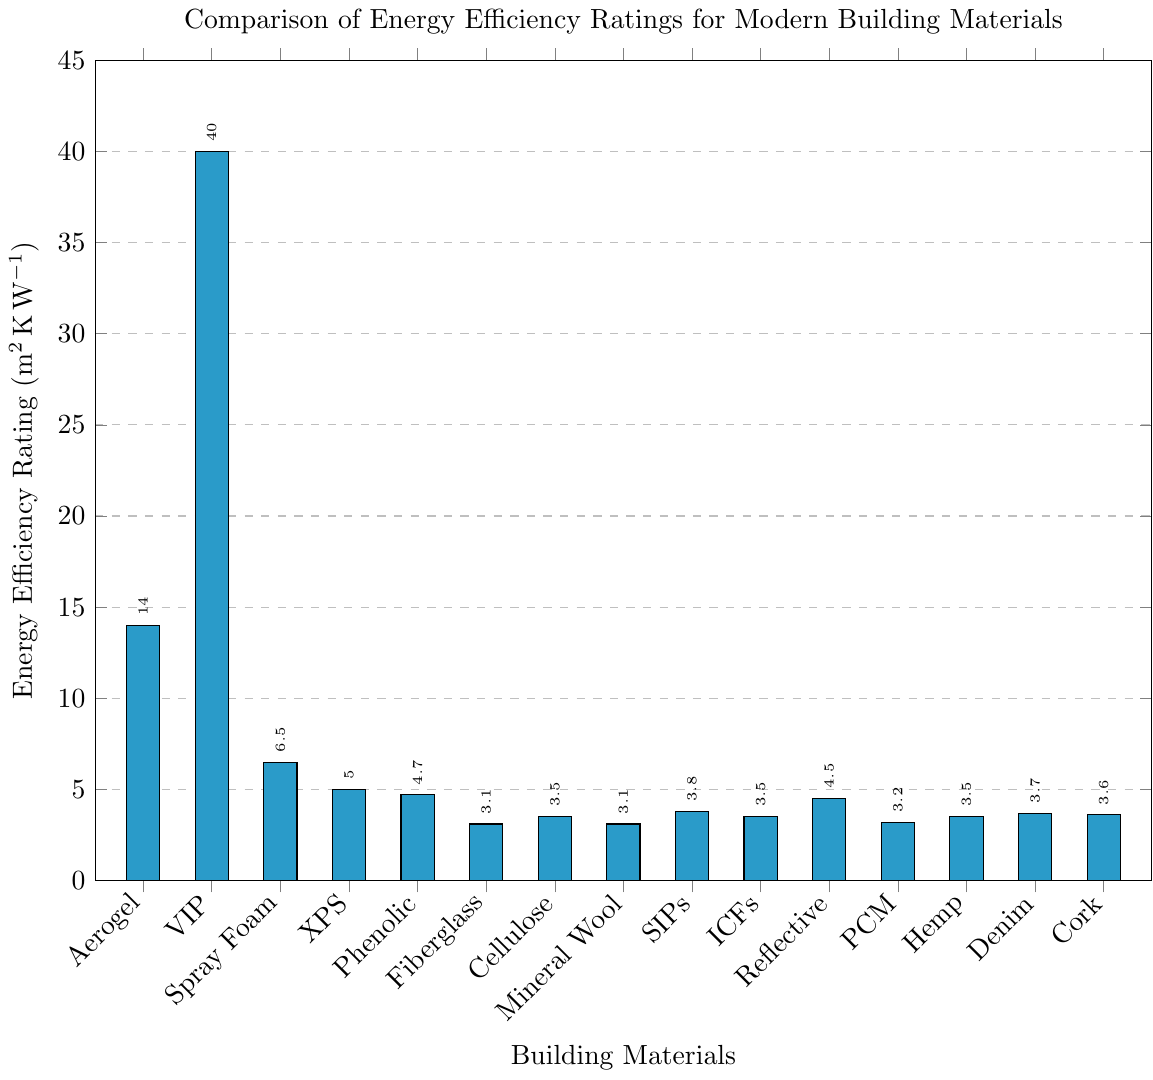Which building material has the highest energy efficiency rating? The figure shows the energy efficiency ratings for various building materials. The tallest bar represents the material with the highest rating.
Answer: Vacuum Insulated Panels What is the difference in energy efficiency rating between Aerogel Insulation and Polyurethane Spray Foam? Locate the bars for Aerogel Insulation and Polyurethane Spray Foam in the figure and note their ratings. Subtract the rating of Polyurethane Spray Foam (6.5) from Aerogel Insulation (14). 14 - 6.5 = 7.5
Answer: 7.5 How many materials have an energy efficiency rating greater than 5? Count the number of bars with a height indicating a rating greater than 5 in the figure. These materials are Aerogel Insulation, Vacuum Insulated Panels, and Polyurethane Spray Foam.
Answer: 3 What is the average energy efficiency rating of Phenolic Foam, Fiberglass Batt, and Cellulose? Find the ratings for Phenolic Foam (4.7), Fiberglass Batt (3.1), and Cellulose (3.5). Sum these values and divide by the number of materials. (4.7 + 3.1 + 3.5) / 3 = 11.3 / 3
Answer: 3.77 Which two materials have the closest energy efficiency ratings? Look at the figure to find two bars with heights that are closest to each other. Fiberglass Batt and Mineral Wool both have ratings of 3.1.
Answer: Fiberglass Batt and Mineral Wool Is Reflective Insulation more energy-efficient than Recycled Denim? Compare the height of the bar for Reflective Insulation (4.5) to Recycled Denim (3.7). Since the bar for Reflective Insulation is taller, it is more energy-efficient.
Answer: Yes What is the combined energy efficiency rating of the three least efficient materials? Identify the materials with the shortest bars: Fiberglass Batt (3.1), Mineral Wool (3.1), and Phase Change Materials (3.2). Sum these values. 3.1 + 3.1 + 3.2 = 9.4
Answer: 9.4 By how much does the energy efficiency rating of Vacuum Insulated Panels exceed that of the combined rating of Cork Insulation and Hemp Insulation? The rating for Vacuum Insulated Panels is 40, for Cork Insulation is 3.6, and for Hemp Insulation is 3.5. First, sum the ratings for Cork Insulation and Hemp Insulation: 3.6 + 3.5 = 7.1. Then, subtract this sum from the rating for Vacuum Insulated Panels: 40 - 7.1 = 32.9
Answer: 32.9 